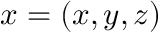<formula> <loc_0><loc_0><loc_500><loc_500>x = \left ( { x , y , z } \right )</formula> 